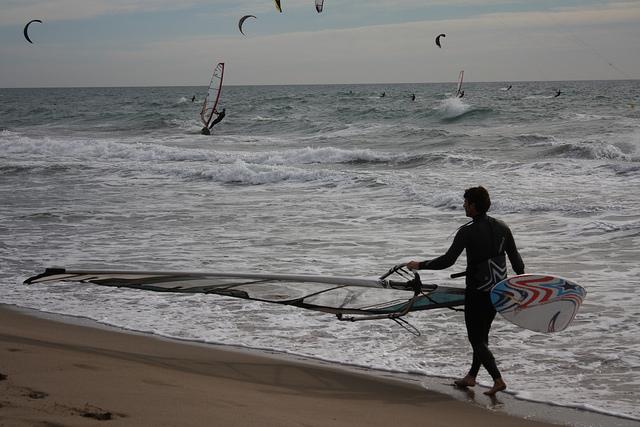Is there a small child?
Write a very short answer. No. What is in this person's hands?
Write a very short answer. Surfboard. What is the man carrying on his shoulders?
Quick response, please. Nothing. Is this a beach?
Short answer required. Yes. Is the surfer on the beach wearing shoes?
Short answer required. No. What is this person carrying?
Keep it brief. Surfboard. Do you see a sailboat in the picture?
Concise answer only. No. Does the man need help to walk?
Give a very brief answer. No. Is this a black and white photo?
Short answer required. No. How many birds are in the picture?
Be succinct. 5. 